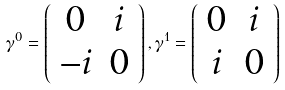<formula> <loc_0><loc_0><loc_500><loc_500>\gamma ^ { 0 } = \left ( \begin{array} { c c } 0 & i \\ - i & 0 \end{array} \right ) , \gamma ^ { 1 } = \left ( \begin{array} { c c } 0 & i \\ i & 0 \end{array} \right )</formula> 